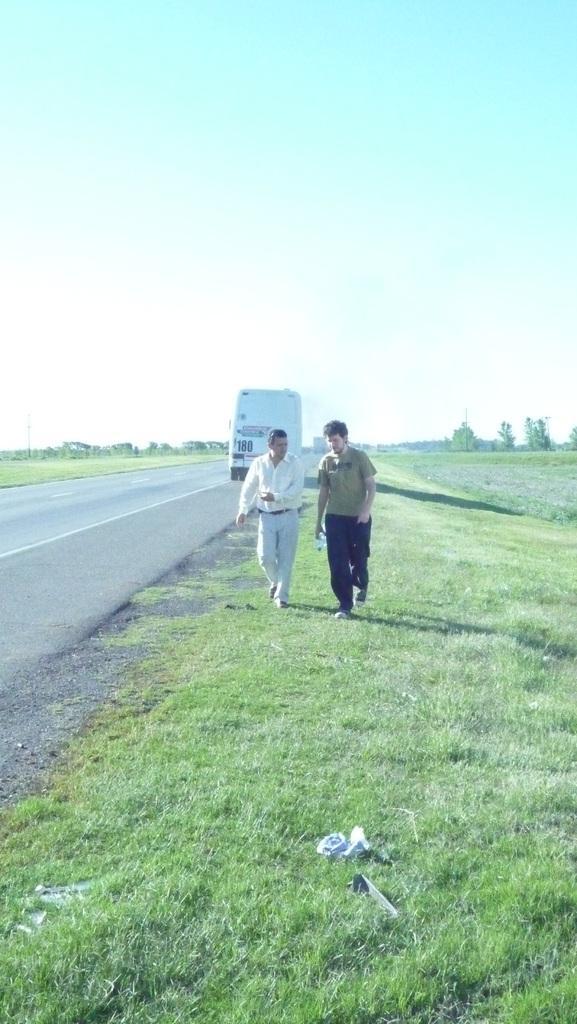Could you give a brief overview of what you see in this image? In the center of the image there are persons walking on the grass. In the background we can see road, vehicles, grass, trees and sky. At the bottom there is a grass. 